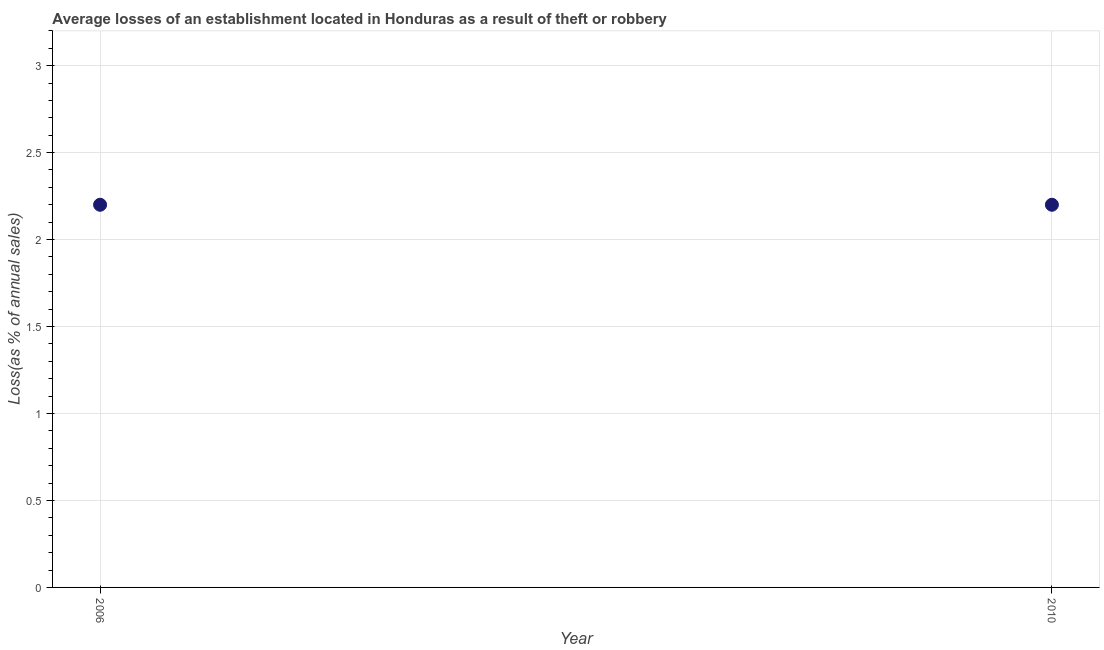What is the losses due to theft in 2006?
Your response must be concise. 2.2. In which year was the losses due to theft minimum?
Give a very brief answer. 2006. What is the average losses due to theft per year?
Make the answer very short. 2.2. In how many years, is the losses due to theft greater than 1.8 %?
Provide a succinct answer. 2. Do a majority of the years between 2006 and 2010 (inclusive) have losses due to theft greater than 2.4 %?
Offer a very short reply. No. In how many years, is the losses due to theft greater than the average losses due to theft taken over all years?
Ensure brevity in your answer.  0. How many dotlines are there?
Make the answer very short. 1. What is the difference between two consecutive major ticks on the Y-axis?
Offer a very short reply. 0.5. Does the graph contain any zero values?
Give a very brief answer. No. Does the graph contain grids?
Your response must be concise. Yes. What is the title of the graph?
Ensure brevity in your answer.  Average losses of an establishment located in Honduras as a result of theft or robbery. What is the label or title of the X-axis?
Provide a short and direct response. Year. What is the label or title of the Y-axis?
Your answer should be compact. Loss(as % of annual sales). What is the Loss(as % of annual sales) in 2006?
Make the answer very short. 2.2. What is the Loss(as % of annual sales) in 2010?
Keep it short and to the point. 2.2. What is the difference between the Loss(as % of annual sales) in 2006 and 2010?
Your answer should be compact. 0. 